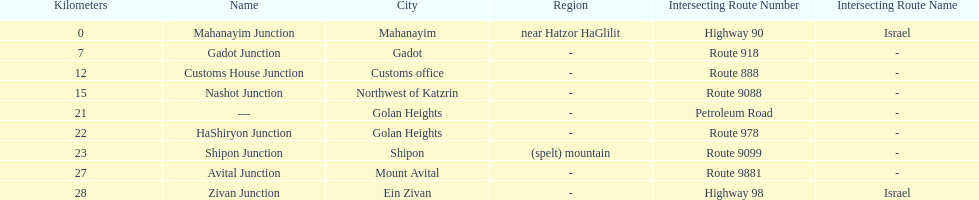Is nashot junction closer to shipon junction or avital junction? Shipon Junction. 